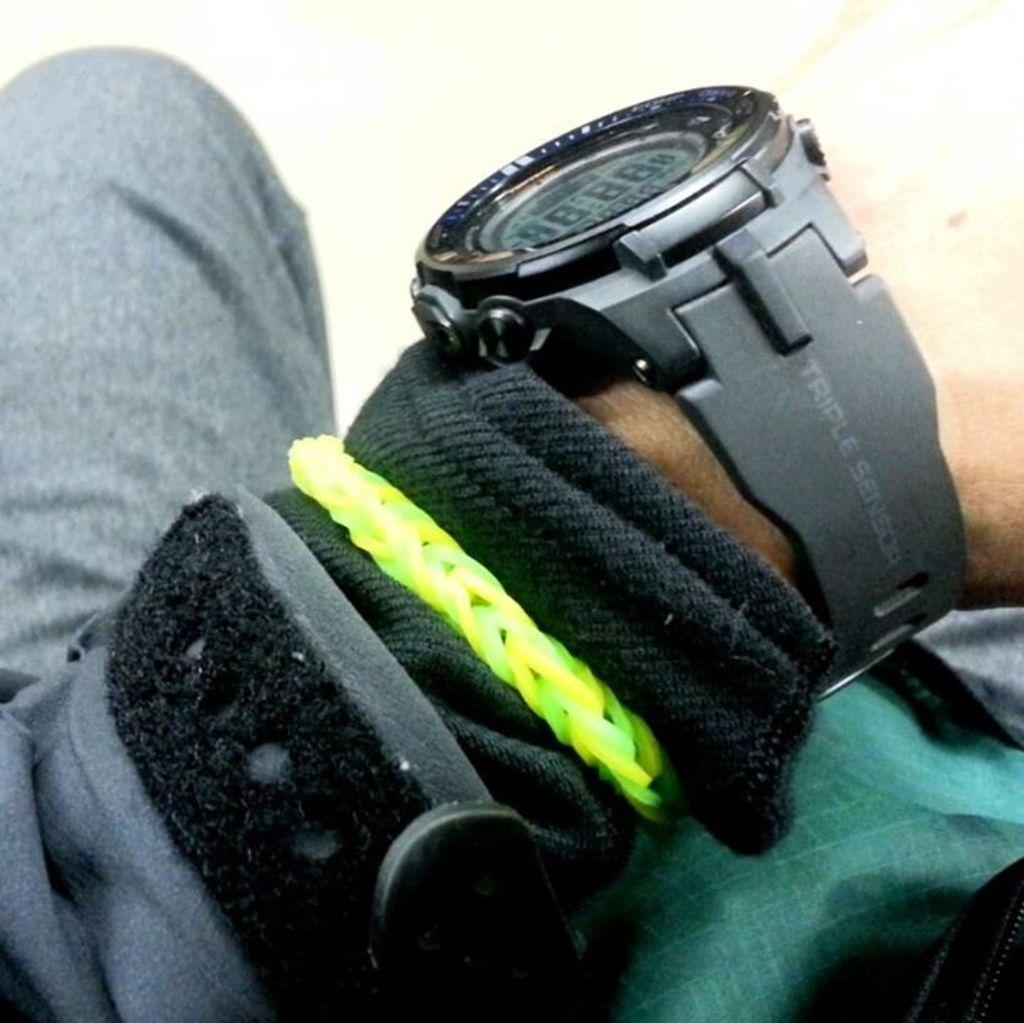<image>
Describe the image concisely. Person wearing a black watch that says "Triple Sensors" on it. 